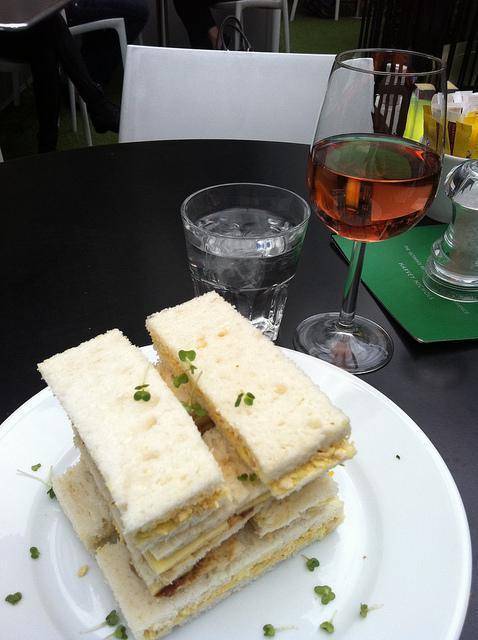How many chairs are there?
Give a very brief answer. 3. 